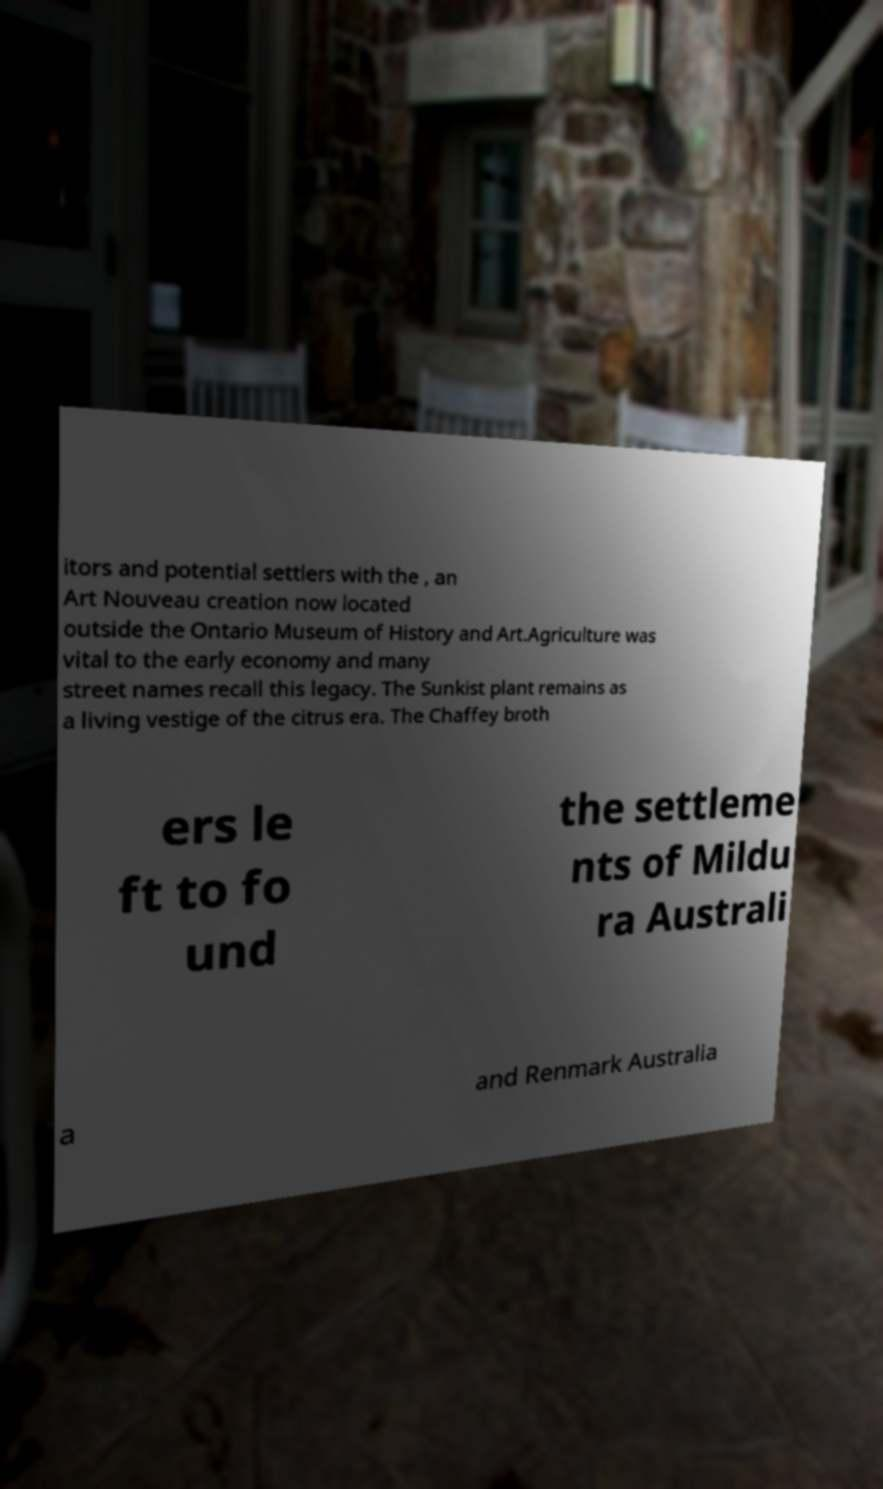Can you accurately transcribe the text from the provided image for me? itors and potential settlers with the , an Art Nouveau creation now located outside the Ontario Museum of History and Art.Agriculture was vital to the early economy and many street names recall this legacy. The Sunkist plant remains as a living vestige of the citrus era. The Chaffey broth ers le ft to fo und the settleme nts of Mildu ra Australi a and Renmark Australia 